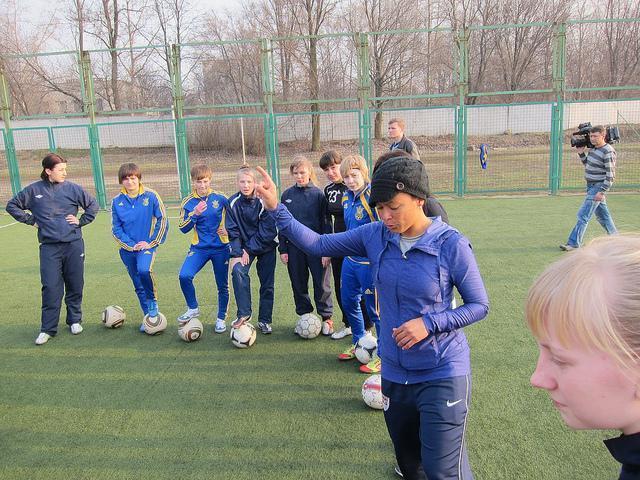How many people in the picture have cameras?
Give a very brief answer. 1. How many people are in the photo?
Give a very brief answer. 9. 